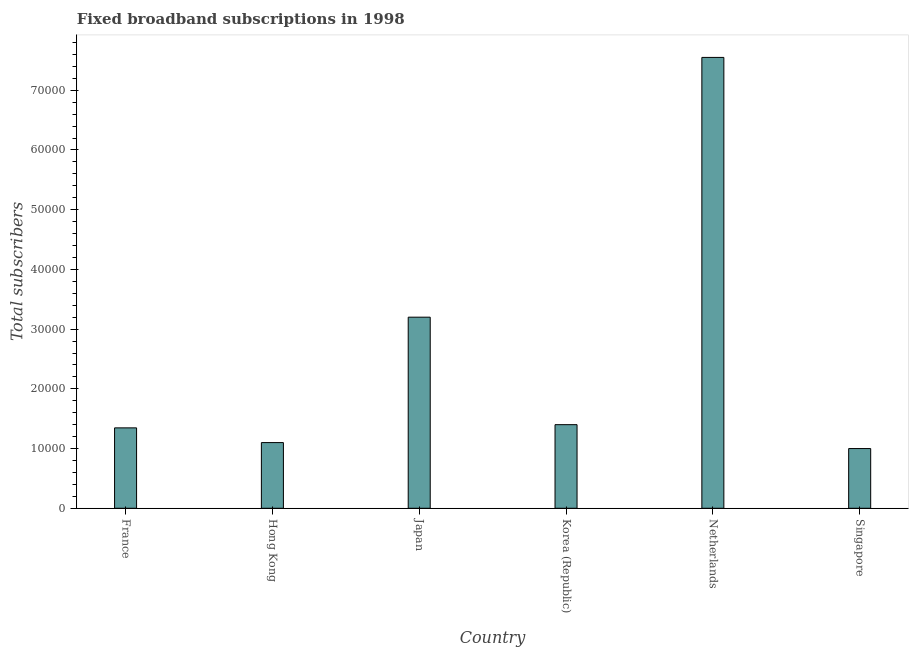What is the title of the graph?
Give a very brief answer. Fixed broadband subscriptions in 1998. What is the label or title of the Y-axis?
Make the answer very short. Total subscribers. What is the total number of fixed broadband subscriptions in Singapore?
Offer a terse response. 10000. Across all countries, what is the maximum total number of fixed broadband subscriptions?
Provide a short and direct response. 7.55e+04. In which country was the total number of fixed broadband subscriptions minimum?
Keep it short and to the point. Singapore. What is the sum of the total number of fixed broadband subscriptions?
Your answer should be very brief. 1.56e+05. What is the difference between the total number of fixed broadband subscriptions in France and Japan?
Provide a short and direct response. -1.85e+04. What is the average total number of fixed broadband subscriptions per country?
Your answer should be very brief. 2.60e+04. What is the median total number of fixed broadband subscriptions?
Keep it short and to the point. 1.37e+04. In how many countries, is the total number of fixed broadband subscriptions greater than 22000 ?
Provide a short and direct response. 2. Is the total number of fixed broadband subscriptions in Netherlands less than that in Singapore?
Provide a succinct answer. No. Is the difference between the total number of fixed broadband subscriptions in Hong Kong and Singapore greater than the difference between any two countries?
Provide a short and direct response. No. What is the difference between the highest and the second highest total number of fixed broadband subscriptions?
Ensure brevity in your answer.  4.35e+04. Is the sum of the total number of fixed broadband subscriptions in Korea (Republic) and Netherlands greater than the maximum total number of fixed broadband subscriptions across all countries?
Make the answer very short. Yes. What is the difference between the highest and the lowest total number of fixed broadband subscriptions?
Give a very brief answer. 6.55e+04. In how many countries, is the total number of fixed broadband subscriptions greater than the average total number of fixed broadband subscriptions taken over all countries?
Your answer should be very brief. 2. How many bars are there?
Your response must be concise. 6. How many countries are there in the graph?
Your answer should be compact. 6. Are the values on the major ticks of Y-axis written in scientific E-notation?
Keep it short and to the point. No. What is the Total subscribers of France?
Give a very brief answer. 1.35e+04. What is the Total subscribers of Hong Kong?
Your response must be concise. 1.10e+04. What is the Total subscribers of Japan?
Make the answer very short. 3.20e+04. What is the Total subscribers of Korea (Republic)?
Keep it short and to the point. 1.40e+04. What is the Total subscribers in Netherlands?
Your answer should be very brief. 7.55e+04. What is the Total subscribers in Singapore?
Offer a terse response. 10000. What is the difference between the Total subscribers in France and Hong Kong?
Your answer should be very brief. 2464. What is the difference between the Total subscribers in France and Japan?
Make the answer very short. -1.85e+04. What is the difference between the Total subscribers in France and Korea (Republic)?
Your response must be concise. -536. What is the difference between the Total subscribers in France and Netherlands?
Offer a very short reply. -6.20e+04. What is the difference between the Total subscribers in France and Singapore?
Keep it short and to the point. 3464. What is the difference between the Total subscribers in Hong Kong and Japan?
Your response must be concise. -2.10e+04. What is the difference between the Total subscribers in Hong Kong and Korea (Republic)?
Ensure brevity in your answer.  -3000. What is the difference between the Total subscribers in Hong Kong and Netherlands?
Your answer should be very brief. -6.45e+04. What is the difference between the Total subscribers in Japan and Korea (Republic)?
Your response must be concise. 1.80e+04. What is the difference between the Total subscribers in Japan and Netherlands?
Provide a succinct answer. -4.35e+04. What is the difference between the Total subscribers in Japan and Singapore?
Give a very brief answer. 2.20e+04. What is the difference between the Total subscribers in Korea (Republic) and Netherlands?
Offer a very short reply. -6.15e+04. What is the difference between the Total subscribers in Korea (Republic) and Singapore?
Provide a succinct answer. 4000. What is the difference between the Total subscribers in Netherlands and Singapore?
Give a very brief answer. 6.55e+04. What is the ratio of the Total subscribers in France to that in Hong Kong?
Keep it short and to the point. 1.22. What is the ratio of the Total subscribers in France to that in Japan?
Keep it short and to the point. 0.42. What is the ratio of the Total subscribers in France to that in Korea (Republic)?
Give a very brief answer. 0.96. What is the ratio of the Total subscribers in France to that in Netherlands?
Your answer should be compact. 0.18. What is the ratio of the Total subscribers in France to that in Singapore?
Provide a short and direct response. 1.35. What is the ratio of the Total subscribers in Hong Kong to that in Japan?
Make the answer very short. 0.34. What is the ratio of the Total subscribers in Hong Kong to that in Korea (Republic)?
Keep it short and to the point. 0.79. What is the ratio of the Total subscribers in Hong Kong to that in Netherlands?
Provide a succinct answer. 0.15. What is the ratio of the Total subscribers in Japan to that in Korea (Republic)?
Your answer should be very brief. 2.29. What is the ratio of the Total subscribers in Japan to that in Netherlands?
Ensure brevity in your answer.  0.42. What is the ratio of the Total subscribers in Japan to that in Singapore?
Ensure brevity in your answer.  3.2. What is the ratio of the Total subscribers in Korea (Republic) to that in Netherlands?
Ensure brevity in your answer.  0.18. What is the ratio of the Total subscribers in Korea (Republic) to that in Singapore?
Your answer should be very brief. 1.4. What is the ratio of the Total subscribers in Netherlands to that in Singapore?
Keep it short and to the point. 7.55. 